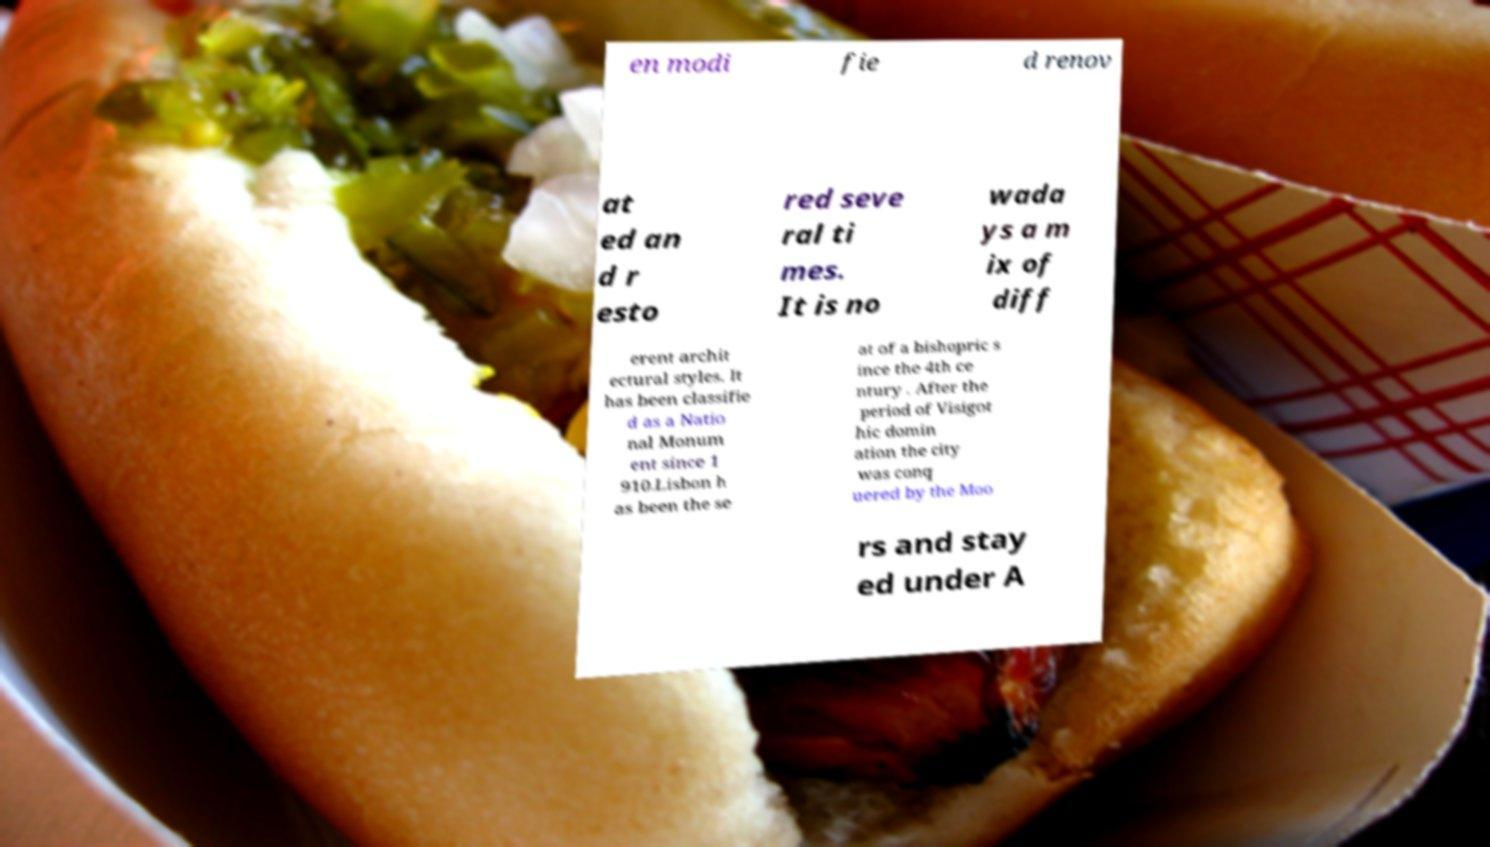Could you extract and type out the text from this image? en modi fie d renov at ed an d r esto red seve ral ti mes. It is no wada ys a m ix of diff erent archit ectural styles. It has been classifie d as a Natio nal Monum ent since 1 910.Lisbon h as been the se at of a bishopric s ince the 4th ce ntury . After the period of Visigot hic domin ation the city was conq uered by the Moo rs and stay ed under A 